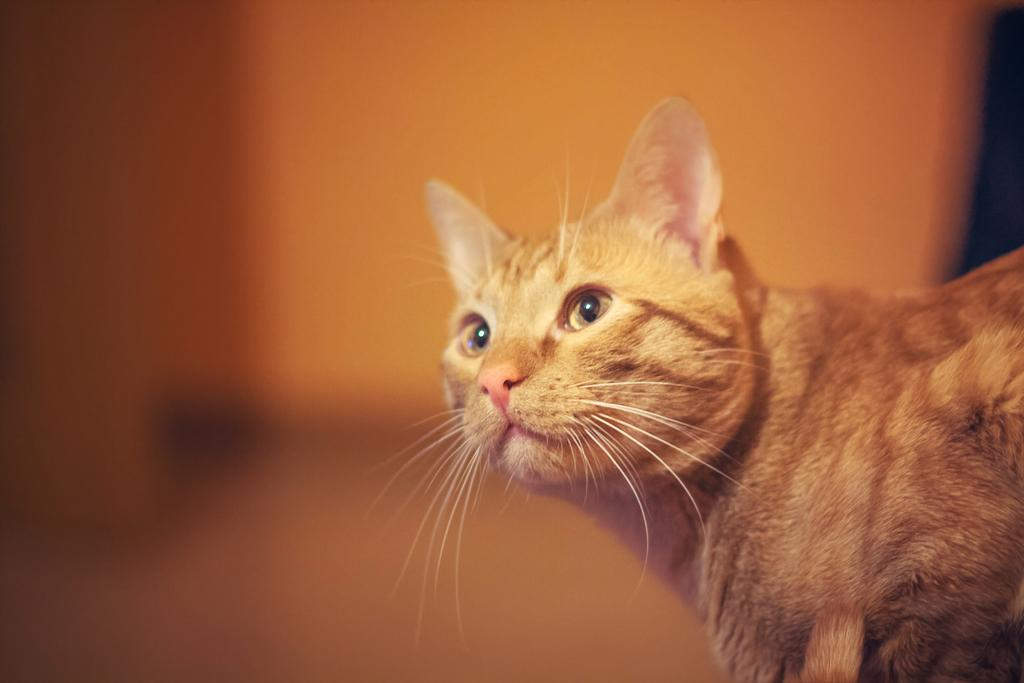What type of animal is in the image? There is a cat in the image. What can be seen in the background of the image? There is a wall in the background of the image. What type of oil is being used by the cat in the image? There is no oil present in the image, and the cat is not using any oil. 